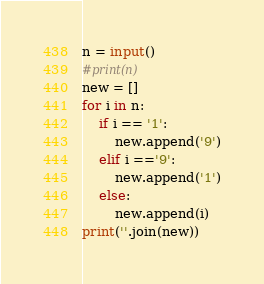Convert code to text. <code><loc_0><loc_0><loc_500><loc_500><_Python_>n = input()
#print(n)
new = []
for i in n:
    if i == '1':
        new.append('9')
    elif i =='9':
        new.append('1')
    else:
        new.append(i)
print(''.join(new))</code> 